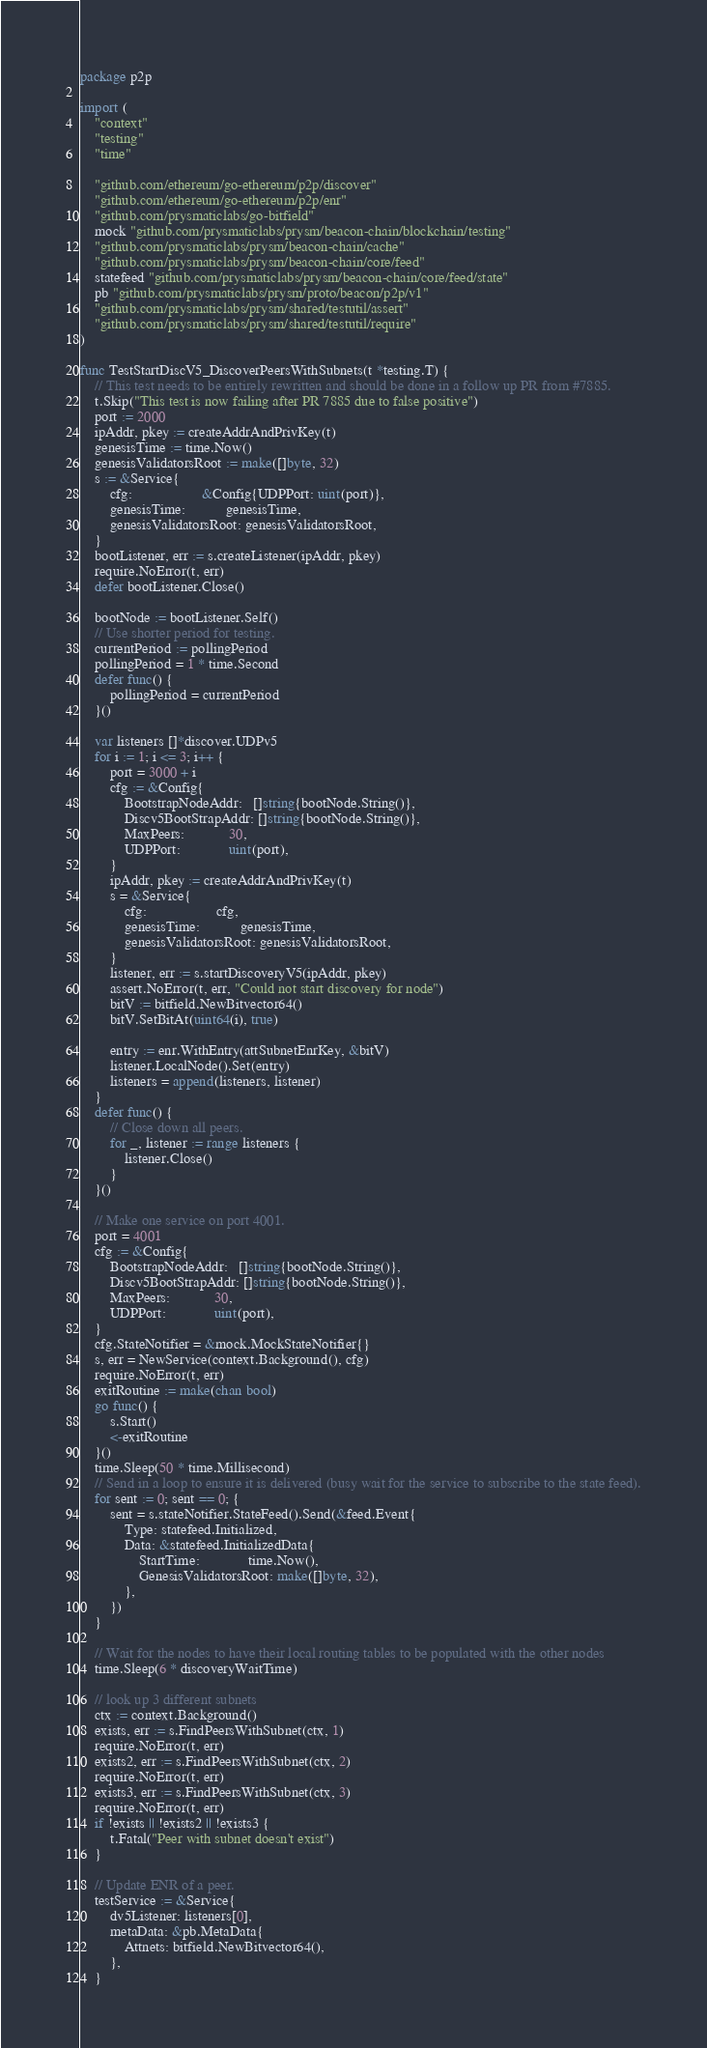<code> <loc_0><loc_0><loc_500><loc_500><_Go_>package p2p

import (
	"context"
	"testing"
	"time"

	"github.com/ethereum/go-ethereum/p2p/discover"
	"github.com/ethereum/go-ethereum/p2p/enr"
	"github.com/prysmaticlabs/go-bitfield"
	mock "github.com/prysmaticlabs/prysm/beacon-chain/blockchain/testing"
	"github.com/prysmaticlabs/prysm/beacon-chain/cache"
	"github.com/prysmaticlabs/prysm/beacon-chain/core/feed"
	statefeed "github.com/prysmaticlabs/prysm/beacon-chain/core/feed/state"
	pb "github.com/prysmaticlabs/prysm/proto/beacon/p2p/v1"
	"github.com/prysmaticlabs/prysm/shared/testutil/assert"
	"github.com/prysmaticlabs/prysm/shared/testutil/require"
)

func TestStartDiscV5_DiscoverPeersWithSubnets(t *testing.T) {
	// This test needs to be entirely rewritten and should be done in a follow up PR from #7885.
	t.Skip("This test is now failing after PR 7885 due to false positive")
	port := 2000
	ipAddr, pkey := createAddrAndPrivKey(t)
	genesisTime := time.Now()
	genesisValidatorsRoot := make([]byte, 32)
	s := &Service{
		cfg:                   &Config{UDPPort: uint(port)},
		genesisTime:           genesisTime,
		genesisValidatorsRoot: genesisValidatorsRoot,
	}
	bootListener, err := s.createListener(ipAddr, pkey)
	require.NoError(t, err)
	defer bootListener.Close()

	bootNode := bootListener.Self()
	// Use shorter period for testing.
	currentPeriod := pollingPeriod
	pollingPeriod = 1 * time.Second
	defer func() {
		pollingPeriod = currentPeriod
	}()

	var listeners []*discover.UDPv5
	for i := 1; i <= 3; i++ {
		port = 3000 + i
		cfg := &Config{
			BootstrapNodeAddr:   []string{bootNode.String()},
			Discv5BootStrapAddr: []string{bootNode.String()},
			MaxPeers:            30,
			UDPPort:             uint(port),
		}
		ipAddr, pkey := createAddrAndPrivKey(t)
		s = &Service{
			cfg:                   cfg,
			genesisTime:           genesisTime,
			genesisValidatorsRoot: genesisValidatorsRoot,
		}
		listener, err := s.startDiscoveryV5(ipAddr, pkey)
		assert.NoError(t, err, "Could not start discovery for node")
		bitV := bitfield.NewBitvector64()
		bitV.SetBitAt(uint64(i), true)

		entry := enr.WithEntry(attSubnetEnrKey, &bitV)
		listener.LocalNode().Set(entry)
		listeners = append(listeners, listener)
	}
	defer func() {
		// Close down all peers.
		for _, listener := range listeners {
			listener.Close()
		}
	}()

	// Make one service on port 4001.
	port = 4001
	cfg := &Config{
		BootstrapNodeAddr:   []string{bootNode.String()},
		Discv5BootStrapAddr: []string{bootNode.String()},
		MaxPeers:            30,
		UDPPort:             uint(port),
	}
	cfg.StateNotifier = &mock.MockStateNotifier{}
	s, err = NewService(context.Background(), cfg)
	require.NoError(t, err)
	exitRoutine := make(chan bool)
	go func() {
		s.Start()
		<-exitRoutine
	}()
	time.Sleep(50 * time.Millisecond)
	// Send in a loop to ensure it is delivered (busy wait for the service to subscribe to the state feed).
	for sent := 0; sent == 0; {
		sent = s.stateNotifier.StateFeed().Send(&feed.Event{
			Type: statefeed.Initialized,
			Data: &statefeed.InitializedData{
				StartTime:             time.Now(),
				GenesisValidatorsRoot: make([]byte, 32),
			},
		})
	}

	// Wait for the nodes to have their local routing tables to be populated with the other nodes
	time.Sleep(6 * discoveryWaitTime)

	// look up 3 different subnets
	ctx := context.Background()
	exists, err := s.FindPeersWithSubnet(ctx, 1)
	require.NoError(t, err)
	exists2, err := s.FindPeersWithSubnet(ctx, 2)
	require.NoError(t, err)
	exists3, err := s.FindPeersWithSubnet(ctx, 3)
	require.NoError(t, err)
	if !exists || !exists2 || !exists3 {
		t.Fatal("Peer with subnet doesn't exist")
	}

	// Update ENR of a peer.
	testService := &Service{
		dv5Listener: listeners[0],
		metaData: &pb.MetaData{
			Attnets: bitfield.NewBitvector64(),
		},
	}</code> 